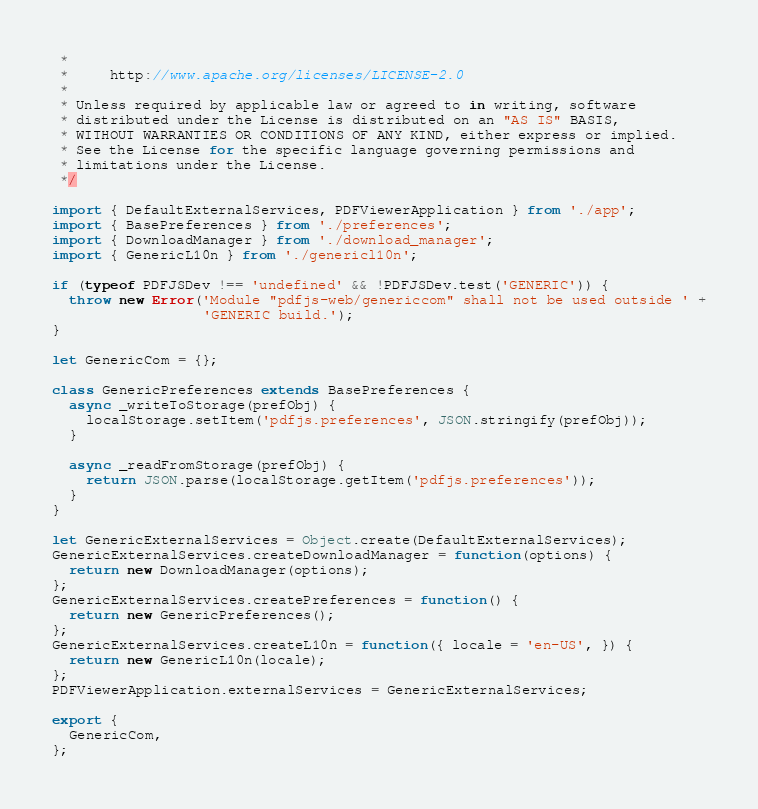Convert code to text. <code><loc_0><loc_0><loc_500><loc_500><_JavaScript_> *
 *     http://www.apache.org/licenses/LICENSE-2.0
 *
 * Unless required by applicable law or agreed to in writing, software
 * distributed under the License is distributed on an "AS IS" BASIS,
 * WITHOUT WARRANTIES OR CONDITIONS OF ANY KIND, either express or implied.
 * See the License for the specific language governing permissions and
 * limitations under the License.
 */

import { DefaultExternalServices, PDFViewerApplication } from './app';
import { BasePreferences } from './preferences';
import { DownloadManager } from './download_manager';
import { GenericL10n } from './genericl10n';

if (typeof PDFJSDev !== 'undefined' && !PDFJSDev.test('GENERIC')) {
  throw new Error('Module "pdfjs-web/genericcom" shall not be used outside ' +
                  'GENERIC build.');
}

let GenericCom = {};

class GenericPreferences extends BasePreferences {
  async _writeToStorage(prefObj) {
    localStorage.setItem('pdfjs.preferences', JSON.stringify(prefObj));
  }

  async _readFromStorage(prefObj) {
    return JSON.parse(localStorage.getItem('pdfjs.preferences'));
  }
}

let GenericExternalServices = Object.create(DefaultExternalServices);
GenericExternalServices.createDownloadManager = function(options) {
  return new DownloadManager(options);
};
GenericExternalServices.createPreferences = function() {
  return new GenericPreferences();
};
GenericExternalServices.createL10n = function({ locale = 'en-US', }) {
  return new GenericL10n(locale);
};
PDFViewerApplication.externalServices = GenericExternalServices;

export {
  GenericCom,
};
</code> 